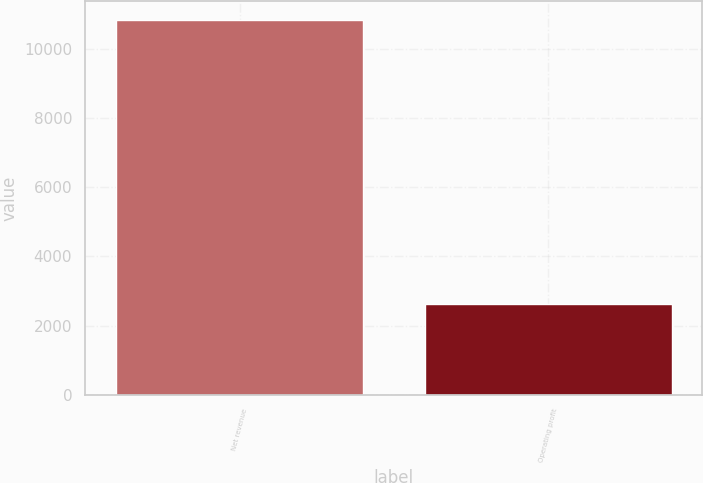<chart> <loc_0><loc_0><loc_500><loc_500><bar_chart><fcel>Net revenue<fcel>Operating profit<nl><fcel>10844<fcel>2615<nl></chart> 